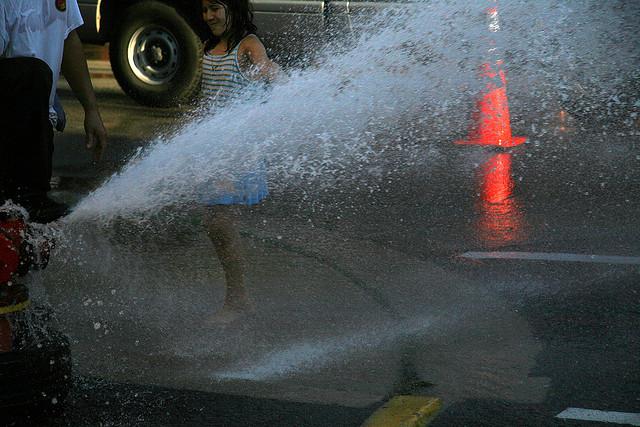How many cones?
Short answer required. 1. Is the girl in the water?
Give a very brief answer. Yes. Is the girl wearing shoes?
Answer briefly. No. 